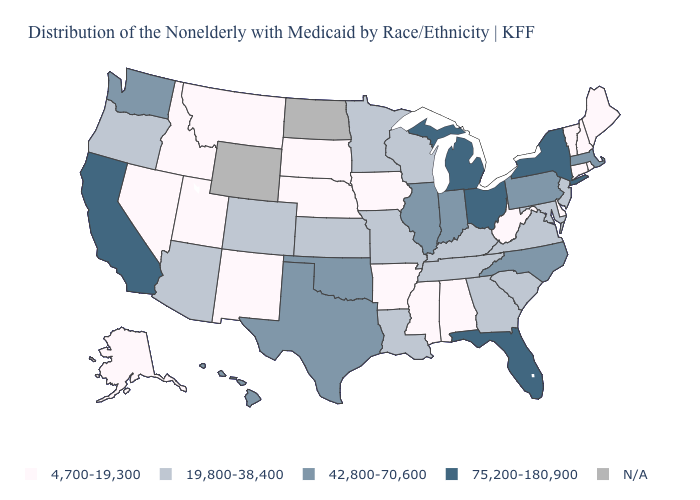Name the states that have a value in the range 75,200-180,900?
Give a very brief answer. California, Florida, Michigan, New York, Ohio. Name the states that have a value in the range 19,800-38,400?
Answer briefly. Arizona, Colorado, Georgia, Kansas, Kentucky, Louisiana, Maryland, Minnesota, Missouri, New Jersey, Oregon, South Carolina, Tennessee, Virginia, Wisconsin. Name the states that have a value in the range 4,700-19,300?
Short answer required. Alabama, Alaska, Arkansas, Connecticut, Delaware, Idaho, Iowa, Maine, Mississippi, Montana, Nebraska, Nevada, New Hampshire, New Mexico, Rhode Island, South Dakota, Utah, Vermont, West Virginia. Among the states that border Rhode Island , does Connecticut have the lowest value?
Quick response, please. Yes. Among the states that border Kansas , which have the highest value?
Keep it brief. Oklahoma. Among the states that border New York , does Vermont have the lowest value?
Short answer required. Yes. Among the states that border Oregon , does Washington have the lowest value?
Short answer required. No. What is the value of Iowa?
Keep it brief. 4,700-19,300. What is the value of Pennsylvania?
Concise answer only. 42,800-70,600. Among the states that border Arizona , which have the lowest value?
Be succinct. Nevada, New Mexico, Utah. What is the value of Colorado?
Write a very short answer. 19,800-38,400. Does the map have missing data?
Concise answer only. Yes. What is the value of Kentucky?
Answer briefly. 19,800-38,400. 